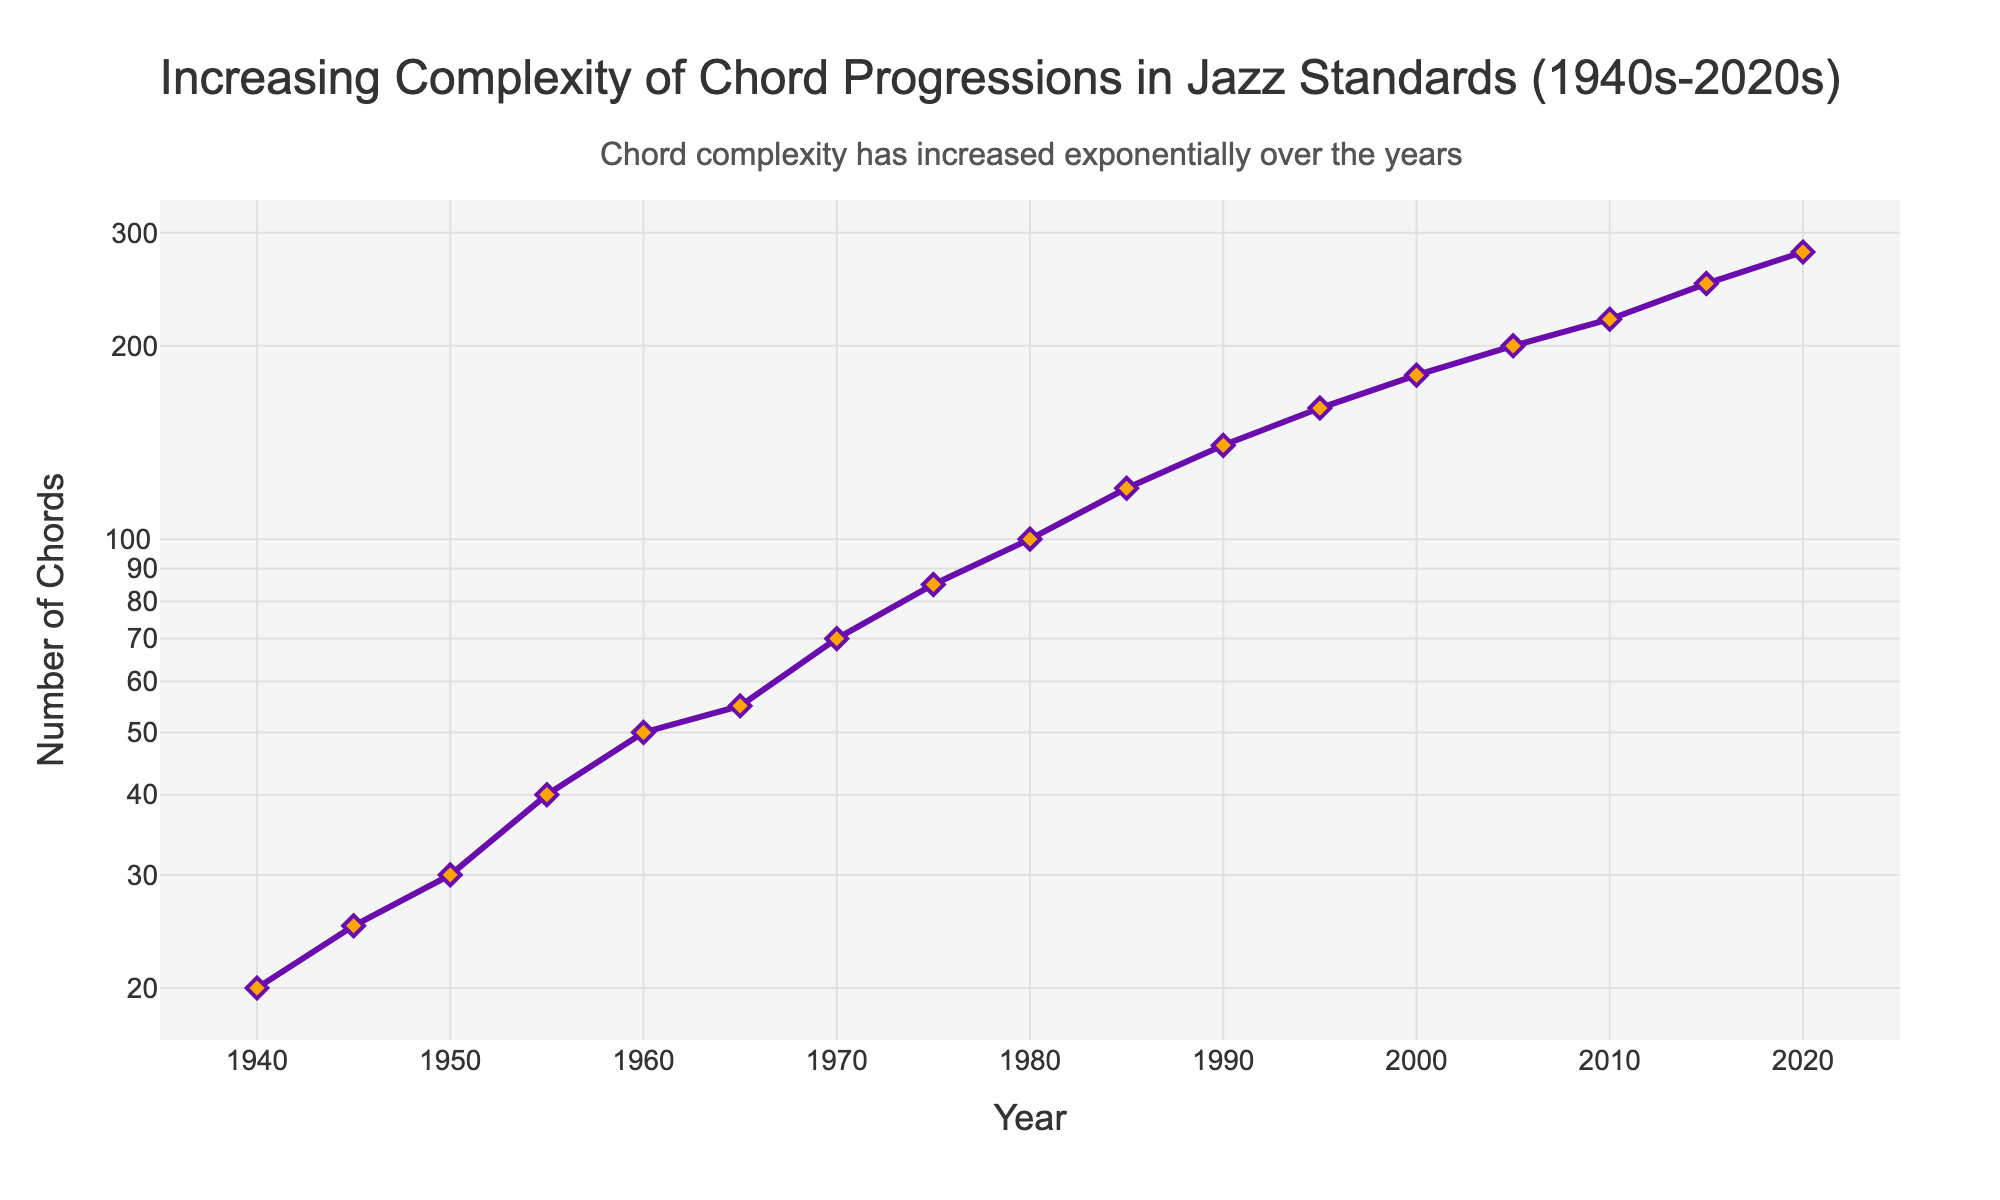what is the highest number of chords used in a single year according to the plot? The plot shows a peak in the number of chords in the year 2020. By looking at the y-axis value for that year, we see that the maximum number of chords used is 280.
Answer: 280 what year marked the first appearance of a significant increase in the number of chords used? Observing the line plot, the steepest increase first occurs around 1955, where the number of chords jumps from 30 in 1950 to 40 in 1955. This marks the start of a notable increase.
Answer: 1955 Which decade had the greatest increase in chord complexity based on the plot? By examining the y-axis values at the decade marks, the biggest increase is found between 2010 and 2020, where the number of chords rises from 220 to 280, an increase of 60 chords.
Answer: 2010s what is the total increase in the number of chords from 1940 to 2020? The number of chords in 1940 is 20, and in 2020 it is 280. The total increase is calculated as 280 - 20 = 260.
Answer: 260 Which year had an equal number of chords compared to 2005? Observing the y-axis value at 2005, we see it is at 200 chords. By comparing to earlier years, 200 chords also appear at 2020 before increasing further.
Answer: 2020 What is the average number of chords used in the 1950s? Only 1950 and 1955 are within the 1950s range in the plot. They are 30 and 40 chords respectively. The average number of chords is (30 + 40) / 2 = 35.
Answer: 35 By how many chords did the complexity increase from 1960 to 1970? The number of chords in 1960 is 50 and in 1970, it is 70. The increase is 70 - 50 = 20 chords.
Answer: 20 What's the exponential growth rate of chord complexity from 1950 to 2020? To calculate the exponential growth rate \(r\), use the formula \(N_t = N_0 e^{rt}\), where \(N_t\) is the final value, \(N_0\) is the initial value, and \(t\) is time in years. Here \(280 = 30 e^{r \cdot 70}\). You solve for \(r\) which requires logarithmic operations and gives an approximate rate of 0.035.
Answer: 0.035 Is the increase in the number of chords more rapid in the second half of the time series (1980-2020) compared to the first half (1940-1980)? The increase from 1940 to 1980 is from 20 to 100, a change of 80 chords. From 1980 to 2020, the increase is from 100 to 280, a change of 180 chords. Therefore, the second half exhibits a more rapid and larger increase.
Answer: Yes What visual evidence suggests an exponential increase in chord complexity over the years? The y-axis, set to a logarithmic scale, shows the number of chords as almost straight linear growth, suggesting an exponential increase since each increment appears evenly spaced on this log scale.
Answer: Logarithmic scale visual comparison 